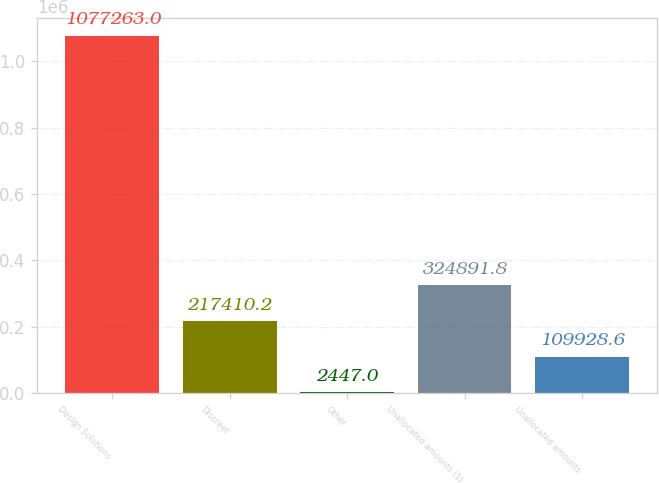Convert chart. <chart><loc_0><loc_0><loc_500><loc_500><bar_chart><fcel>Design Solutions<fcel>Discreet<fcel>Other<fcel>Unallocated amounts (1)<fcel>Unallocated amounts<nl><fcel>1.07726e+06<fcel>217410<fcel>2447<fcel>324892<fcel>109929<nl></chart> 